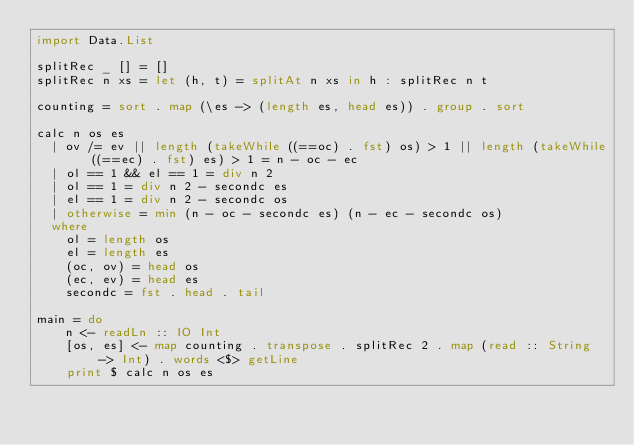<code> <loc_0><loc_0><loc_500><loc_500><_Haskell_>import Data.List

splitRec _ [] = []
splitRec n xs = let (h, t) = splitAt n xs in h : splitRec n t

counting = sort . map (\es -> (length es, head es)) . group . sort 

calc n os es
  | ov /= ev || length (takeWhile ((==oc) . fst) os) > 1 || length (takeWhile ((==ec) . fst) es) > 1 = n - oc - ec
  | ol == 1 && el == 1 = div n 2
  | ol == 1 = div n 2 - secondc es
  | el == 1 = div n 2 - secondc os
  | otherwise = min (n - oc - secondc es) (n - ec - secondc os)
  where
    ol = length os
    el = length es
    (oc, ov) = head os
    (ec, ev) = head es
    secondc = fst . head . tail

main = do
    n <- readLn :: IO Int
    [os, es] <- map counting . transpose . splitRec 2 . map (read :: String -> Int) . words <$> getLine
    print $ calc n os es</code> 